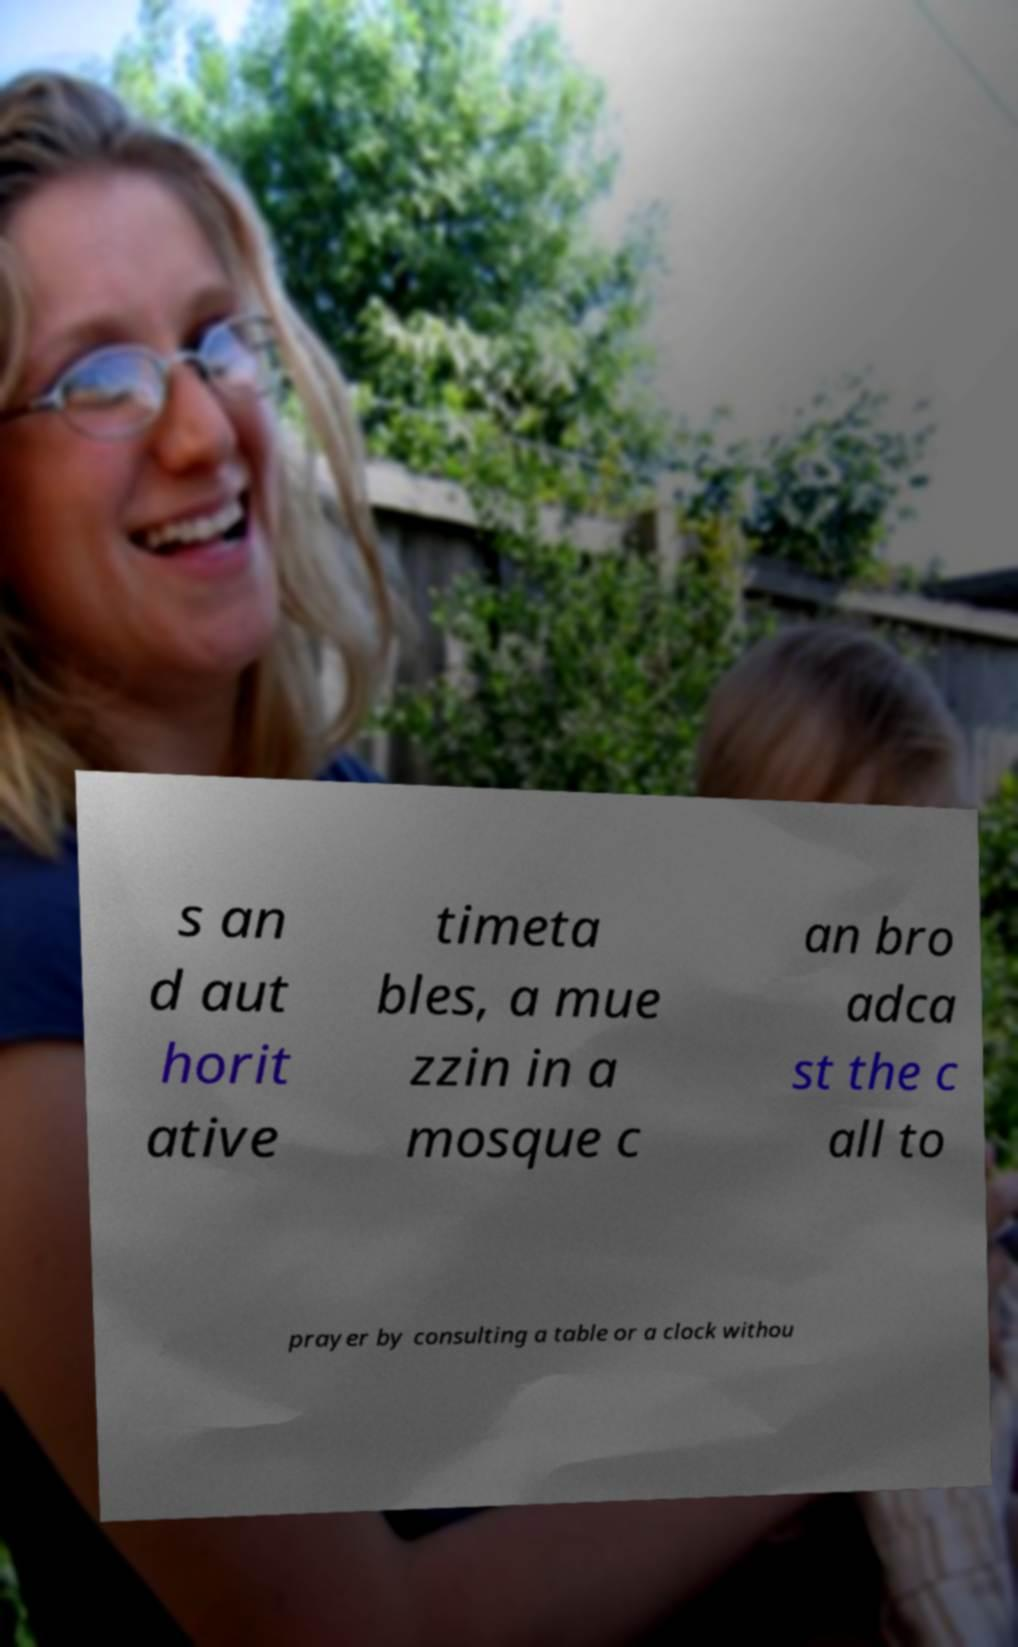Could you assist in decoding the text presented in this image and type it out clearly? s an d aut horit ative timeta bles, a mue zzin in a mosque c an bro adca st the c all to prayer by consulting a table or a clock withou 